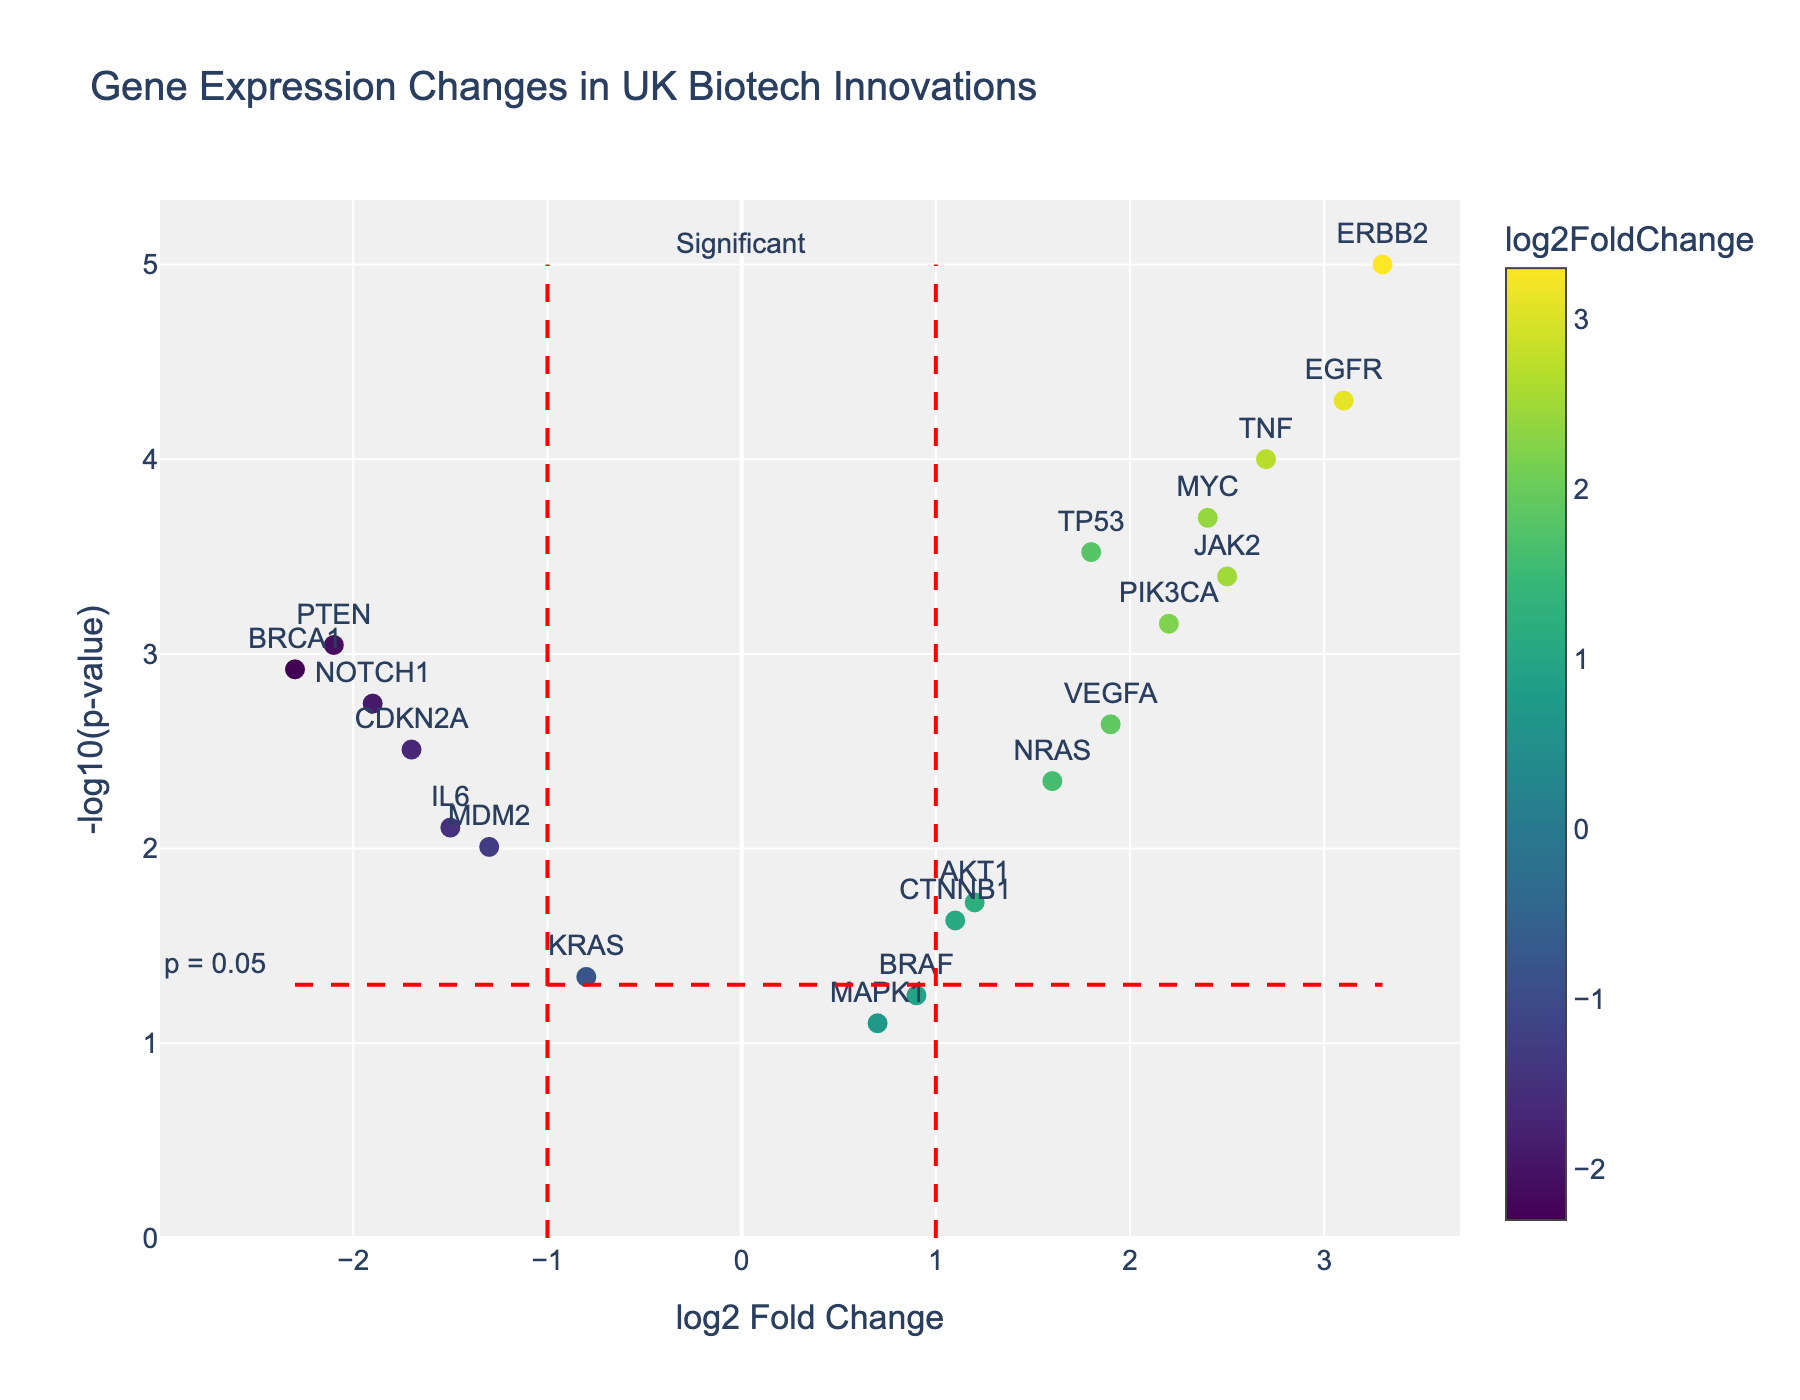What is the title of the plot? The title is usually located at the top center of the plot. In this plot, it reads "Gene Expression Changes in UK Biotech Innovations."
Answer: Gene Expression Changes in UK Biotech Innovations What is the x-axis title of the plot? The x-axis title is typically found below the x-axis line. In this plot, it reads "log2 Fold Change."
Answer: log2 Fold Change How many genes have a negative log2 fold change? To determine this, count the number of data points (genes) that fall to the left of the vertical line at x = 0. There are 7 genes with negative log2 fold change.
Answer: 7 Which gene has the highest log2 fold change? Identify the data point with the highest x-value. The gene ERBB2 has the highest log2 fold change at 3.3.
Answer: ERBB2 What is the significance threshold represented by the horizontal dashed red line? The horizontal red dashed line represents the p-value threshold of 0.05. The line is at -log10(0.05), which is approximately 1.3.
Answer: 1.3 Which gene has the smallest p-value? The smallest p-value corresponds to the highest y-value on the plot. The gene EGFR has the smallest p-value.
Answer: EGFR How many genes have a p-value lower than the significance threshold? Count the number of data points above the horizontal red dashed line at -log10(0.05). There are 11 genes with a p-value lower than the significance threshold.
Answer: 11 Are there any genes with a log2 fold change between -1 and 1? To find this, look for data points within the vertical lines positioned at x = -1 and x = 1. Genes AKT1, NRAS, BRAF, MAPK1, and CTNNB1 are within this range.
Answer: Yes Which gene is more significantly upregulated, TP53 or JAK2? Compare the y-values (-log10(p-value)) of TP53 and JAK2. The gene JAK2 has a higher y-value, indicating it is more significantly upregulated.
Answer: JAK2 What are the log2 fold change and p-value for the gene BRCA1? Find the data point labeled BRCA1. From the hover text, BRCA1 has a log2 fold change of -2.3 and a p-value of 0.0012.
Answer: log2 fold change: -2.3, p-value: 0.0012 